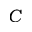<formula> <loc_0><loc_0><loc_500><loc_500>C</formula> 